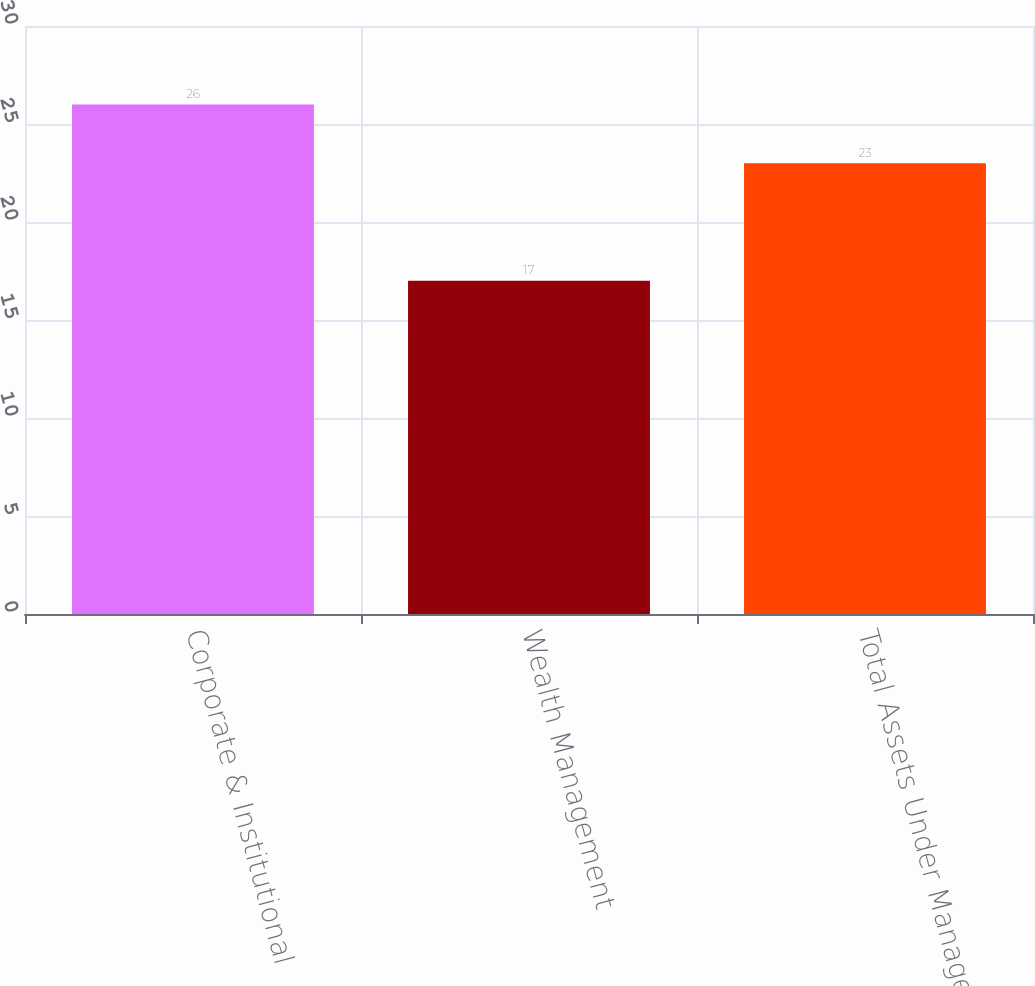Convert chart to OTSL. <chart><loc_0><loc_0><loc_500><loc_500><bar_chart><fcel>Corporate & Institutional<fcel>Wealth Management<fcel>Total Assets Under Management<nl><fcel>26<fcel>17<fcel>23<nl></chart> 